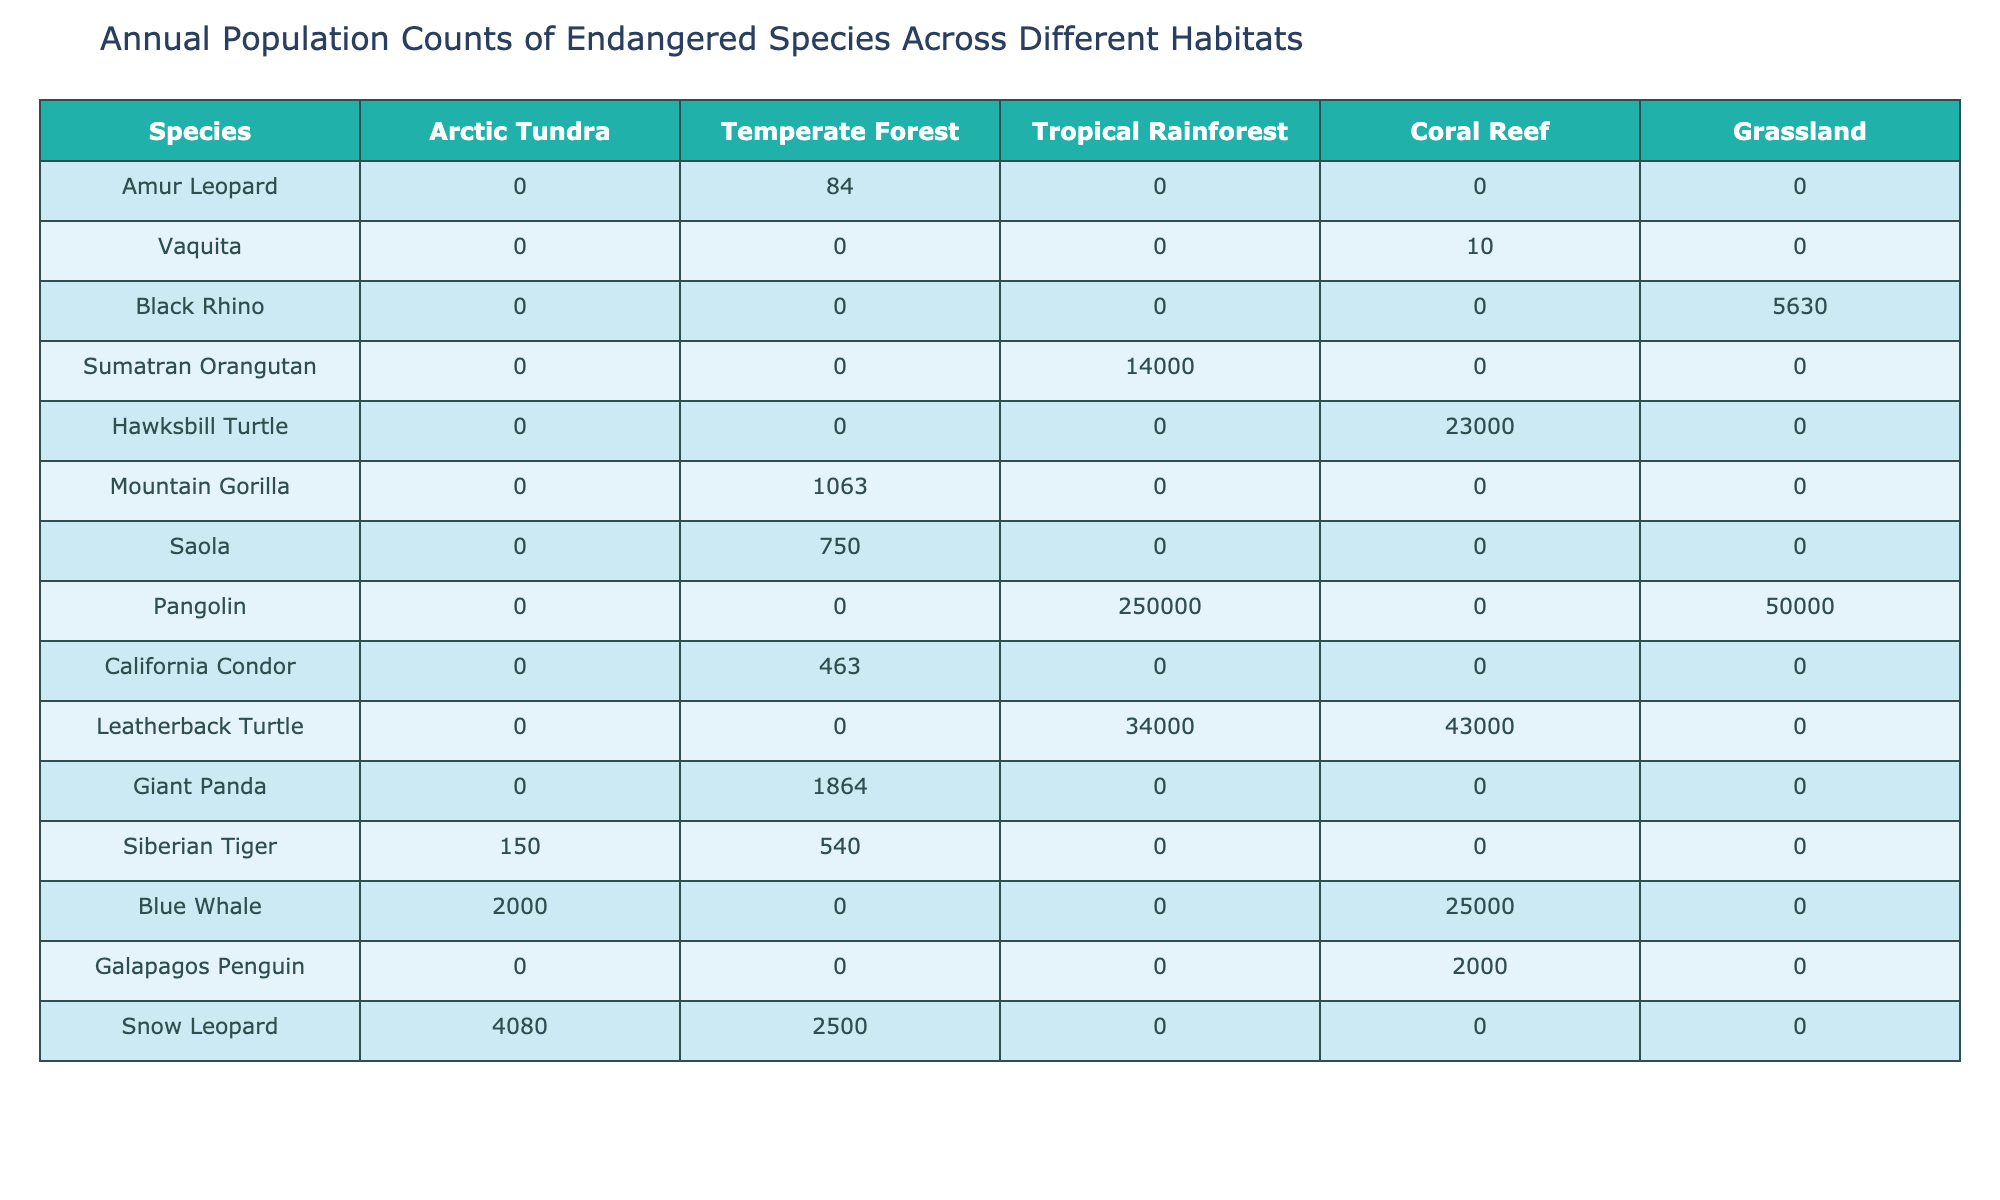What is the total population count of the Amur Leopard across all habitats? The Amur Leopard has a population count of 0 in all habitats listed (Arctic Tundra, Temperate Forest, Tropical Rainforest, Coral Reef, Grassland). Therefore, the total population count is 0.
Answer: 0 How many species have a population count greater than 10 in the Coral Reef habitat? In the Coral Reef habitat, the following species have counts greater than 10: Vaquita (10), Hawksbill Turtle (23000), Leatherback Turtle (43000), and Blue Whale (25000). This totals four species.
Answer: 4 What is the population count of the Siberian Tiger in the Temperate Forest habitat? The Siberian Tiger has a population count of 540 in the Temperate Forest habitat as shown in the table.
Answer: 540 Which species has the highest population in the Tropical Rainforest habitat? The Sumatran Orangutan has the highest population with a total of 14000, which is more than any other species in that habitat.
Answer: Sumatran Orangutan Calculate the total population across all habitats for the Leatherback Turtle. The population count for the Leatherback Turtle is as follows: Arctic Tundra (0) + Temperate Forest (0) + Tropical Rainforest (34000) + Coral Reef (43000) + Grassland (0) = 77000.
Answer: 77000 Is there any species that appears in both the Arctic Tundra and Grassland habitats? Upon reviewing the table, no species are listed with population counts in both the Arctic Tundra and Grassland habitats; all counts in these habitats are 0 for each species except for the Snow Leopard in the Arctic Tundra.
Answer: No What is the average population count of species in the Grassland habitat? The population counts for Grassland are Black Rhino (5630), Sumatran Orangutan (0), Pangolin (50000), California Condor (0), and no others. Thus, the average is (5630 + 0 + 50000 + 0)/3 (excluding species with zeros) = 18543.33. The average is rounded to two decimals.
Answer: 18543.33 Which habitat supports the highest total population of endangered species? Summing the populations across the habitats reveals: Arctic Tundra (4080) + Temperate Forest (4500) + Tropical Rainforest (250000) + Coral Reef (66300) + Grassland (5630) = 275510. The Tropical Rainforest has the highest total at 250000.
Answer: Tropical Rainforest What is the difference in population count of Snow Leopard between Arctic Tundra and Temperate Forest? The Snow Leopard has a population of 4080 in the Arctic Tundra and 2500 in the Temperate Forest. The difference is 4080 - 2500 = 1580.
Answer: 1580 